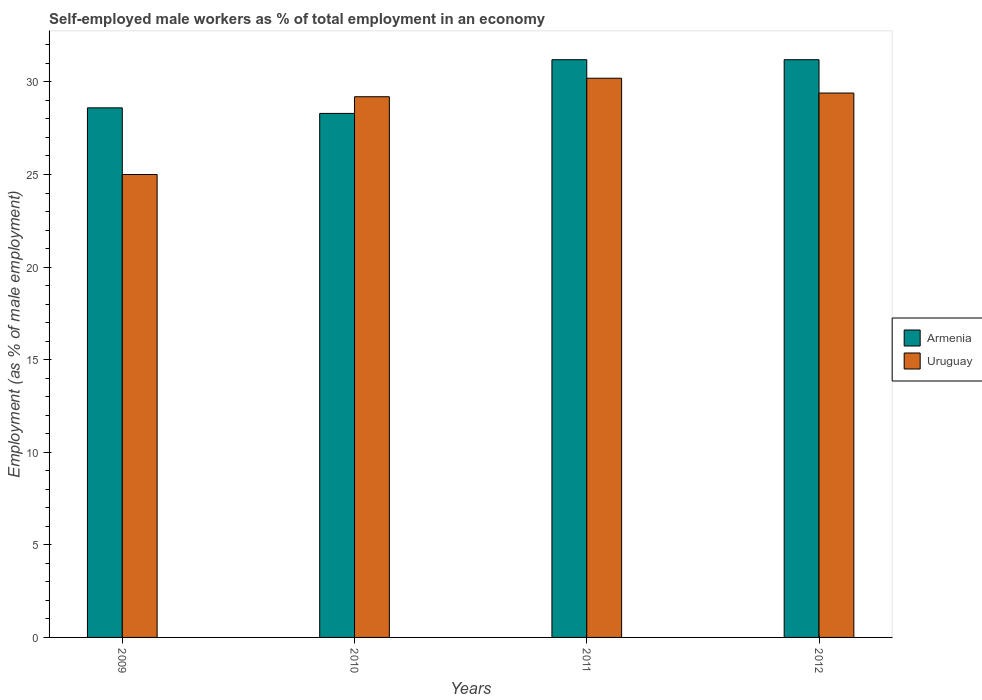How many different coloured bars are there?
Provide a short and direct response. 2. How many groups of bars are there?
Make the answer very short. 4. Are the number of bars per tick equal to the number of legend labels?
Keep it short and to the point. Yes. Are the number of bars on each tick of the X-axis equal?
Your answer should be compact. Yes. How many bars are there on the 2nd tick from the right?
Keep it short and to the point. 2. What is the percentage of self-employed male workers in Armenia in 2012?
Make the answer very short. 31.2. Across all years, what is the maximum percentage of self-employed male workers in Armenia?
Offer a very short reply. 31.2. Across all years, what is the minimum percentage of self-employed male workers in Uruguay?
Provide a short and direct response. 25. What is the total percentage of self-employed male workers in Uruguay in the graph?
Offer a terse response. 113.8. What is the difference between the percentage of self-employed male workers in Armenia in 2010 and that in 2011?
Offer a terse response. -2.9. What is the difference between the percentage of self-employed male workers in Armenia in 2010 and the percentage of self-employed male workers in Uruguay in 2009?
Your answer should be very brief. 3.3. What is the average percentage of self-employed male workers in Armenia per year?
Your answer should be compact. 29.83. In the year 2009, what is the difference between the percentage of self-employed male workers in Armenia and percentage of self-employed male workers in Uruguay?
Keep it short and to the point. 3.6. What is the ratio of the percentage of self-employed male workers in Uruguay in 2009 to that in 2012?
Offer a terse response. 0.85. Is the percentage of self-employed male workers in Uruguay in 2010 less than that in 2012?
Keep it short and to the point. Yes. What is the difference between the highest and the second highest percentage of self-employed male workers in Uruguay?
Your answer should be very brief. 0.8. What is the difference between the highest and the lowest percentage of self-employed male workers in Uruguay?
Ensure brevity in your answer.  5.2. Is the sum of the percentage of self-employed male workers in Armenia in 2009 and 2011 greater than the maximum percentage of self-employed male workers in Uruguay across all years?
Keep it short and to the point. Yes. What does the 2nd bar from the left in 2012 represents?
Your response must be concise. Uruguay. What does the 1st bar from the right in 2012 represents?
Your answer should be very brief. Uruguay. How many bars are there?
Your answer should be compact. 8. How many years are there in the graph?
Keep it short and to the point. 4. What is the difference between two consecutive major ticks on the Y-axis?
Ensure brevity in your answer.  5. Does the graph contain any zero values?
Offer a very short reply. No. How many legend labels are there?
Ensure brevity in your answer.  2. How are the legend labels stacked?
Make the answer very short. Vertical. What is the title of the graph?
Your response must be concise. Self-employed male workers as % of total employment in an economy. Does "Haiti" appear as one of the legend labels in the graph?
Provide a succinct answer. No. What is the label or title of the X-axis?
Give a very brief answer. Years. What is the label or title of the Y-axis?
Offer a very short reply. Employment (as % of male employment). What is the Employment (as % of male employment) in Armenia in 2009?
Keep it short and to the point. 28.6. What is the Employment (as % of male employment) of Uruguay in 2009?
Keep it short and to the point. 25. What is the Employment (as % of male employment) in Armenia in 2010?
Provide a short and direct response. 28.3. What is the Employment (as % of male employment) of Uruguay in 2010?
Provide a succinct answer. 29.2. What is the Employment (as % of male employment) of Armenia in 2011?
Ensure brevity in your answer.  31.2. What is the Employment (as % of male employment) of Uruguay in 2011?
Offer a very short reply. 30.2. What is the Employment (as % of male employment) of Armenia in 2012?
Give a very brief answer. 31.2. What is the Employment (as % of male employment) in Uruguay in 2012?
Keep it short and to the point. 29.4. Across all years, what is the maximum Employment (as % of male employment) of Armenia?
Offer a very short reply. 31.2. Across all years, what is the maximum Employment (as % of male employment) of Uruguay?
Keep it short and to the point. 30.2. Across all years, what is the minimum Employment (as % of male employment) of Armenia?
Offer a very short reply. 28.3. Across all years, what is the minimum Employment (as % of male employment) of Uruguay?
Give a very brief answer. 25. What is the total Employment (as % of male employment) in Armenia in the graph?
Your answer should be compact. 119.3. What is the total Employment (as % of male employment) of Uruguay in the graph?
Offer a very short reply. 113.8. What is the difference between the Employment (as % of male employment) of Armenia in 2009 and that in 2010?
Your answer should be compact. 0.3. What is the difference between the Employment (as % of male employment) of Uruguay in 2009 and that in 2010?
Your answer should be very brief. -4.2. What is the difference between the Employment (as % of male employment) in Armenia in 2009 and that in 2011?
Ensure brevity in your answer.  -2.6. What is the difference between the Employment (as % of male employment) in Uruguay in 2009 and that in 2011?
Give a very brief answer. -5.2. What is the difference between the Employment (as % of male employment) in Uruguay in 2009 and that in 2012?
Your answer should be compact. -4.4. What is the difference between the Employment (as % of male employment) of Armenia in 2010 and that in 2011?
Give a very brief answer. -2.9. What is the difference between the Employment (as % of male employment) of Uruguay in 2010 and that in 2011?
Offer a very short reply. -1. What is the difference between the Employment (as % of male employment) of Armenia in 2010 and that in 2012?
Your answer should be compact. -2.9. What is the difference between the Employment (as % of male employment) in Uruguay in 2011 and that in 2012?
Make the answer very short. 0.8. What is the difference between the Employment (as % of male employment) of Armenia in 2009 and the Employment (as % of male employment) of Uruguay in 2010?
Provide a short and direct response. -0.6. What is the difference between the Employment (as % of male employment) of Armenia in 2010 and the Employment (as % of male employment) of Uruguay in 2011?
Offer a terse response. -1.9. What is the difference between the Employment (as % of male employment) in Armenia in 2011 and the Employment (as % of male employment) in Uruguay in 2012?
Ensure brevity in your answer.  1.8. What is the average Employment (as % of male employment) in Armenia per year?
Offer a very short reply. 29.82. What is the average Employment (as % of male employment) in Uruguay per year?
Your answer should be compact. 28.45. In the year 2010, what is the difference between the Employment (as % of male employment) of Armenia and Employment (as % of male employment) of Uruguay?
Your answer should be compact. -0.9. In the year 2012, what is the difference between the Employment (as % of male employment) of Armenia and Employment (as % of male employment) of Uruguay?
Your answer should be very brief. 1.8. What is the ratio of the Employment (as % of male employment) in Armenia in 2009 to that in 2010?
Make the answer very short. 1.01. What is the ratio of the Employment (as % of male employment) of Uruguay in 2009 to that in 2010?
Make the answer very short. 0.86. What is the ratio of the Employment (as % of male employment) in Armenia in 2009 to that in 2011?
Provide a succinct answer. 0.92. What is the ratio of the Employment (as % of male employment) in Uruguay in 2009 to that in 2011?
Ensure brevity in your answer.  0.83. What is the ratio of the Employment (as % of male employment) in Uruguay in 2009 to that in 2012?
Give a very brief answer. 0.85. What is the ratio of the Employment (as % of male employment) of Armenia in 2010 to that in 2011?
Your answer should be compact. 0.91. What is the ratio of the Employment (as % of male employment) of Uruguay in 2010 to that in 2011?
Keep it short and to the point. 0.97. What is the ratio of the Employment (as % of male employment) in Armenia in 2010 to that in 2012?
Provide a short and direct response. 0.91. What is the ratio of the Employment (as % of male employment) in Uruguay in 2011 to that in 2012?
Provide a short and direct response. 1.03. What is the difference between the highest and the second highest Employment (as % of male employment) in Uruguay?
Offer a terse response. 0.8. 